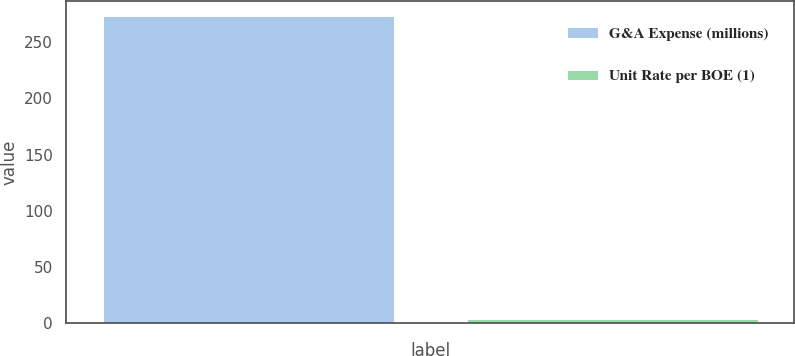Convert chart. <chart><loc_0><loc_0><loc_500><loc_500><bar_chart><fcel>G&A Expense (millions)<fcel>Unit Rate per BOE (1)<nl><fcel>273<fcel>3.65<nl></chart> 